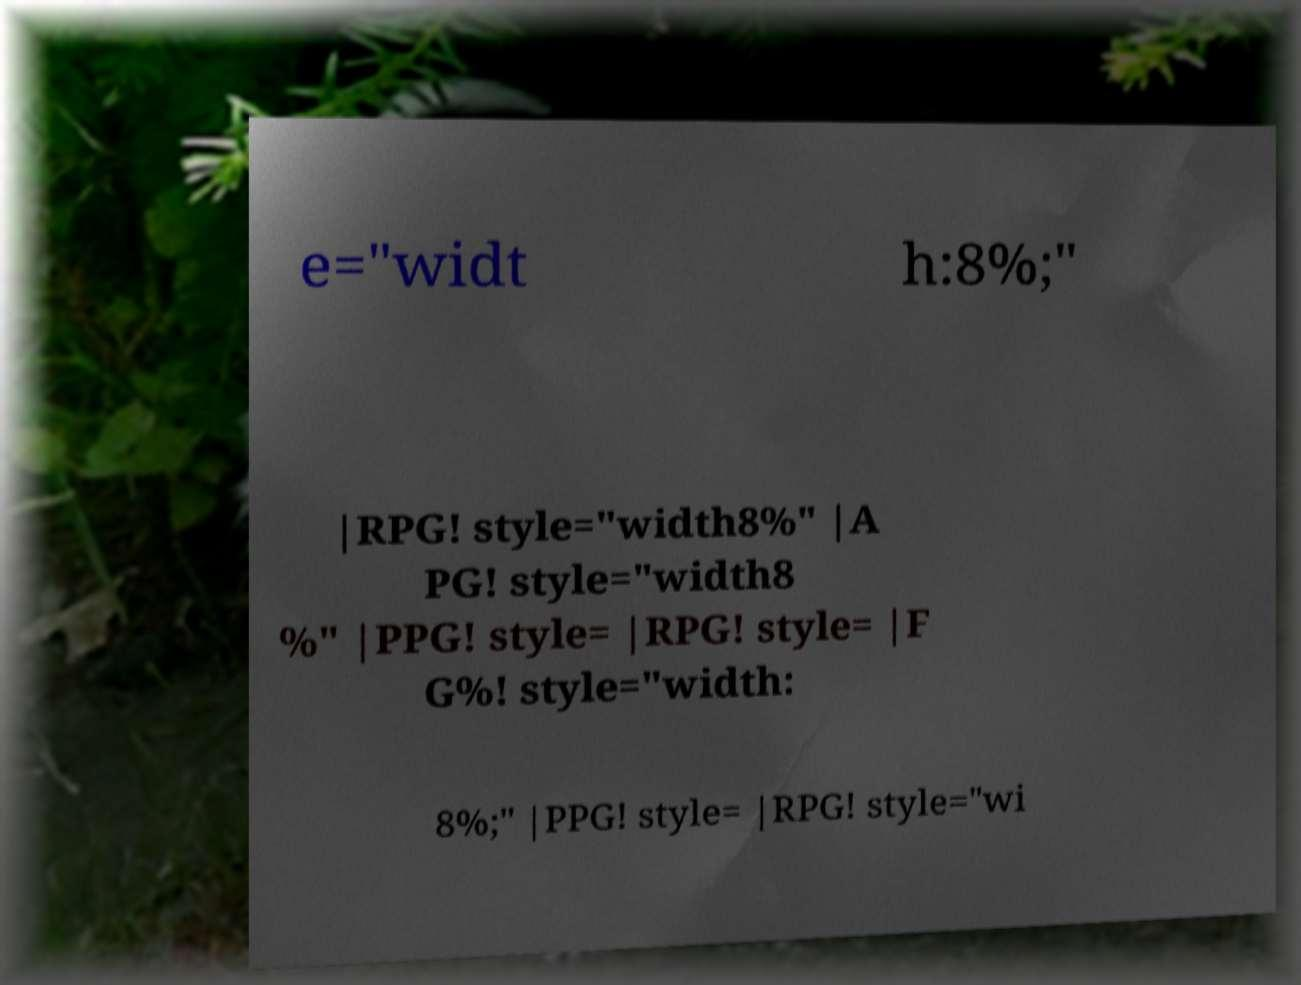Please identify and transcribe the text found in this image. e="widt h:8%;" |RPG! style="width8%" |A PG! style="width8 %" |PPG! style= |RPG! style= |F G%! style="width: 8%;" |PPG! style= |RPG! style="wi 